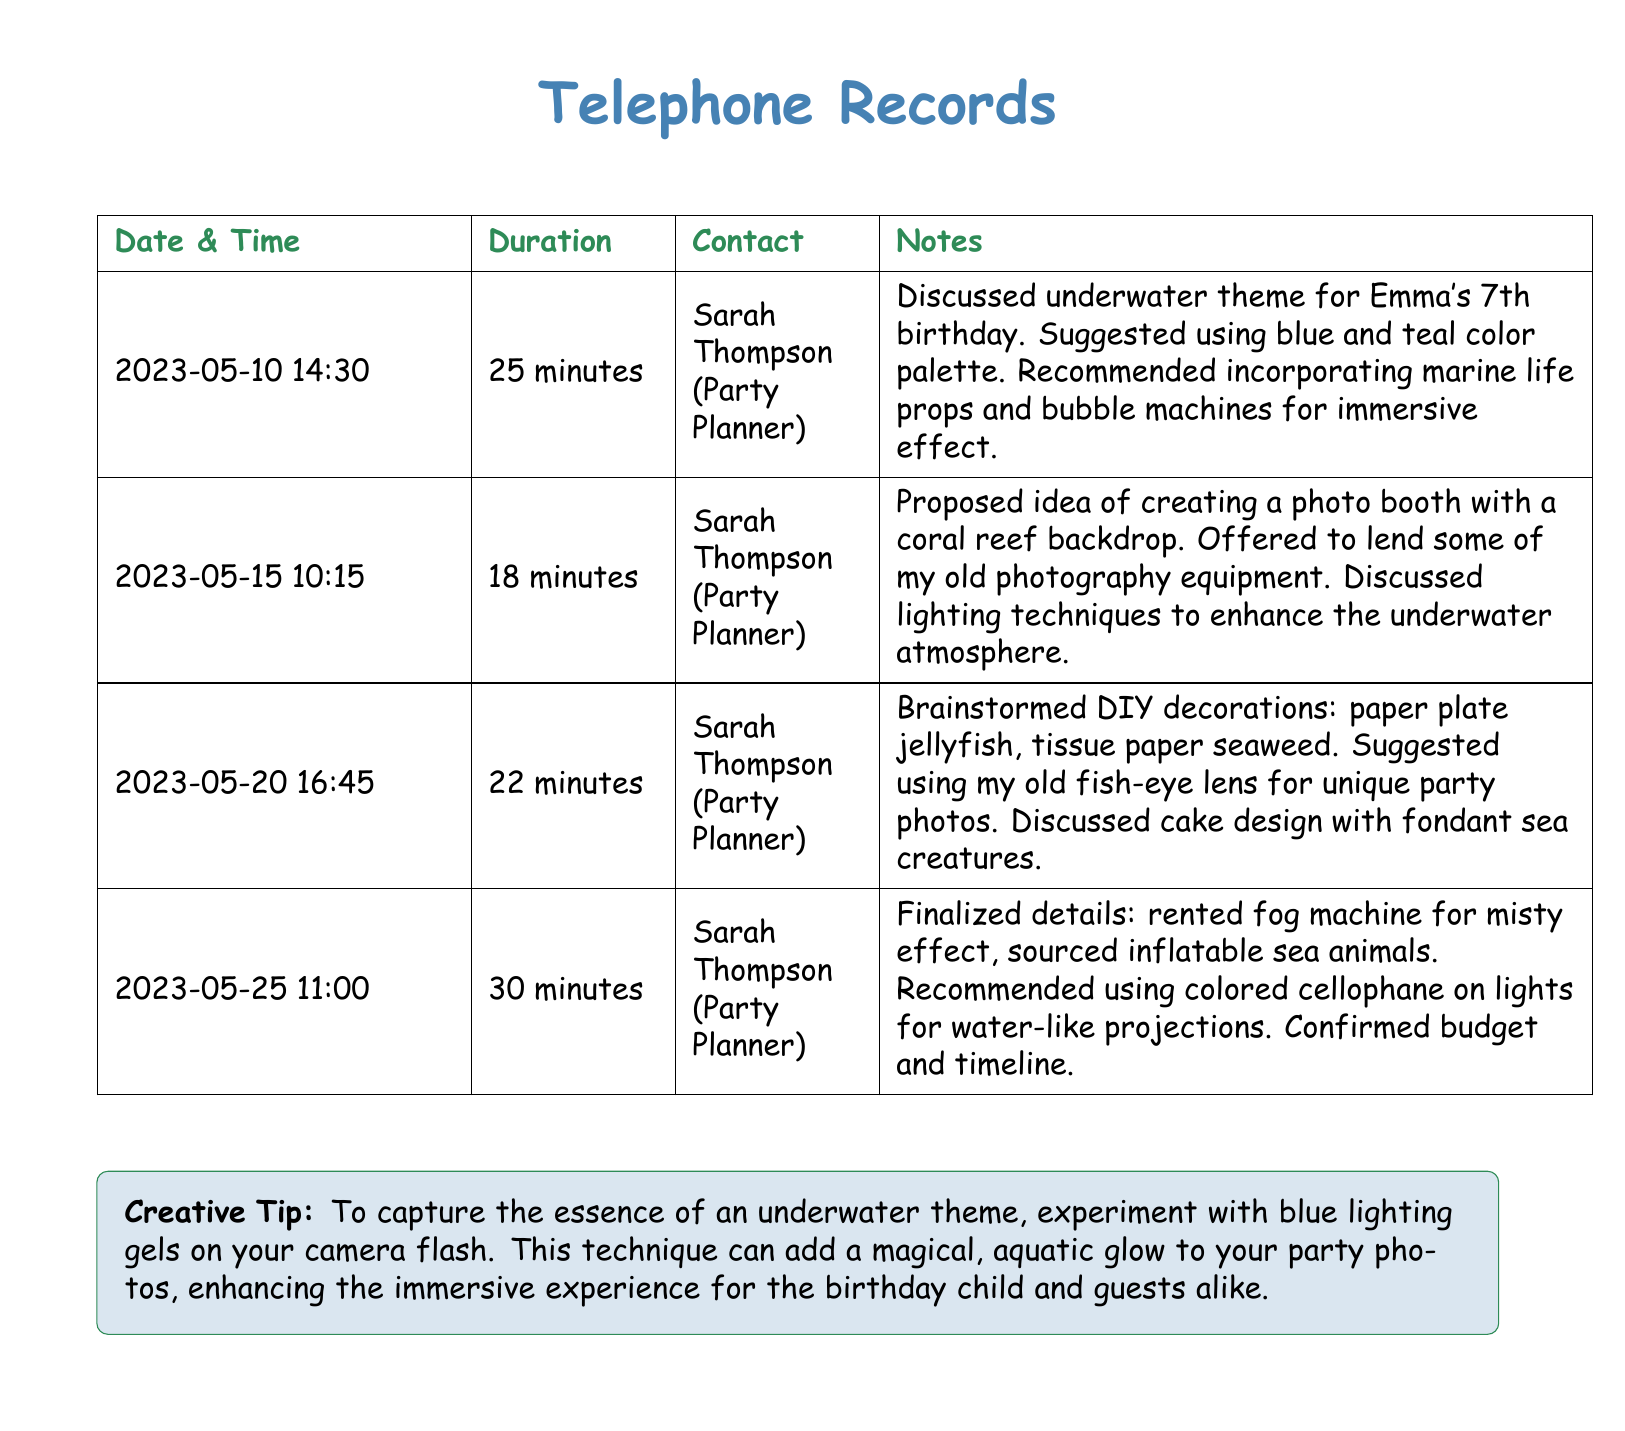What is the date of the first call? The first call occurred on May 10, 2023.
Answer: May 10, 2023 Who is the party planner mentioned in the records? The telephone records refer to Sarah Thompson as the party planner.
Answer: Sarah Thompson How long was the longest conversation? The longest conversation took place on May 25, lasting for 30 minutes.
Answer: 30 minutes What theme was discussed for the birthday party? The conversations centered around an underwater theme for Emma's birthday.
Answer: Underwater theme What creative item was suggested for the photo booth? The idea proposed for the photo booth was a coral reef backdrop.
Answer: Coral reef backdrop How many minutes did the second call last? The second call lasted 18 minutes on May 15.
Answer: 18 minutes What type of decorations were brainstormed during the calls? DIY decorations included paper plate jellyfish and tissue paper seaweed.
Answer: Paper plate jellyfish, tissue paper seaweed What visual effect was recommended for the party photos? A suggestion was made to use blue lighting gels on the camera flash for magical effects.
Answer: Blue lighting gels 